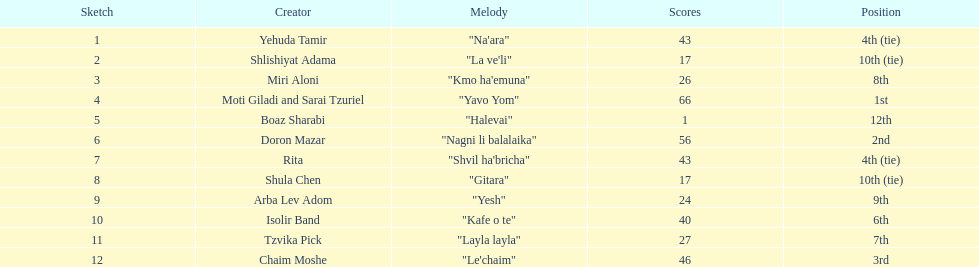Doron mazar, which artist(s) had the most points? Moti Giladi and Sarai Tzuriel. 